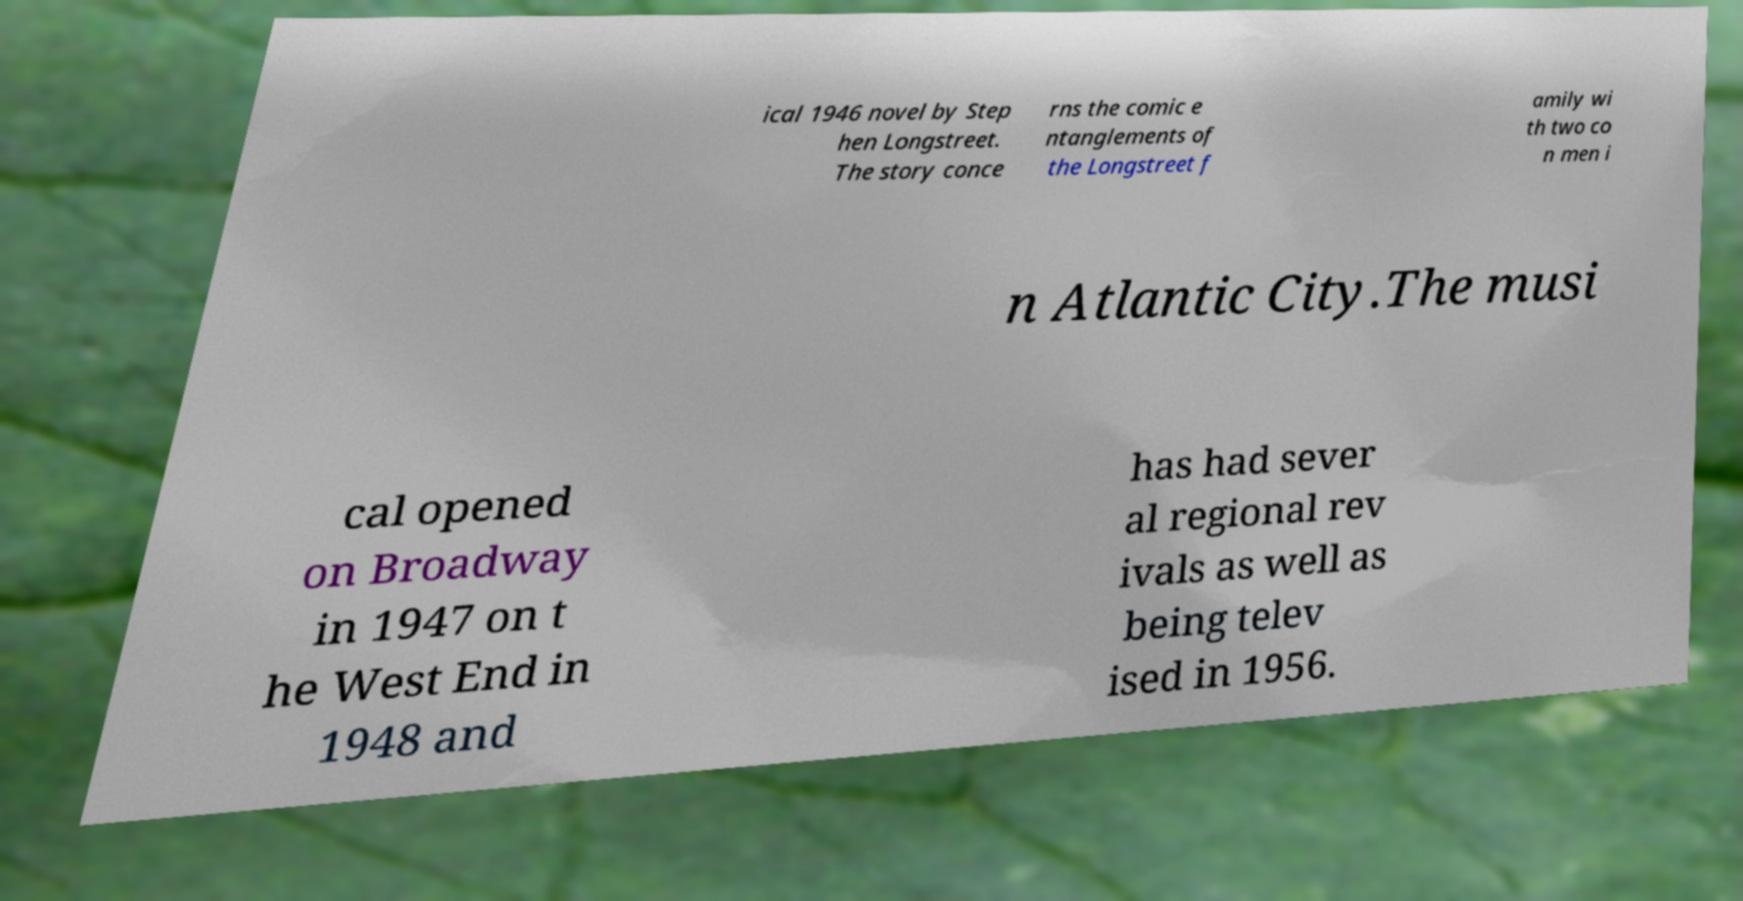Please identify and transcribe the text found in this image. ical 1946 novel by Step hen Longstreet. The story conce rns the comic e ntanglements of the Longstreet f amily wi th two co n men i n Atlantic City.The musi cal opened on Broadway in 1947 on t he West End in 1948 and has had sever al regional rev ivals as well as being telev ised in 1956. 